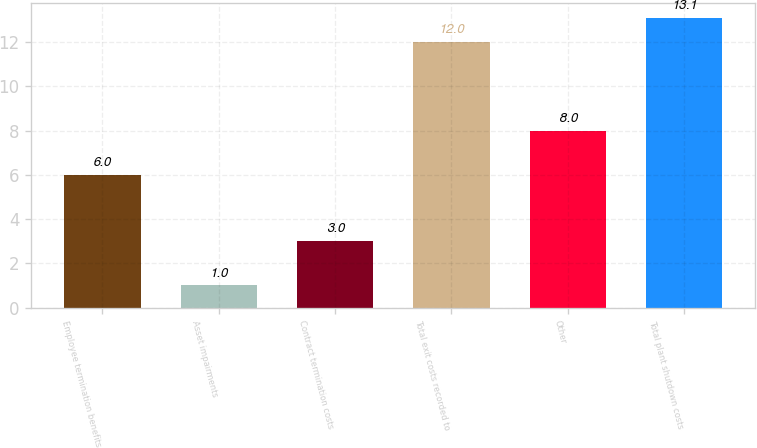Convert chart. <chart><loc_0><loc_0><loc_500><loc_500><bar_chart><fcel>Employee termination benefits<fcel>Asset impairments<fcel>Contract termination costs<fcel>Total exit costs recorded to<fcel>Other<fcel>Total plant shutdown costs<nl><fcel>6<fcel>1<fcel>3<fcel>12<fcel>8<fcel>13.1<nl></chart> 